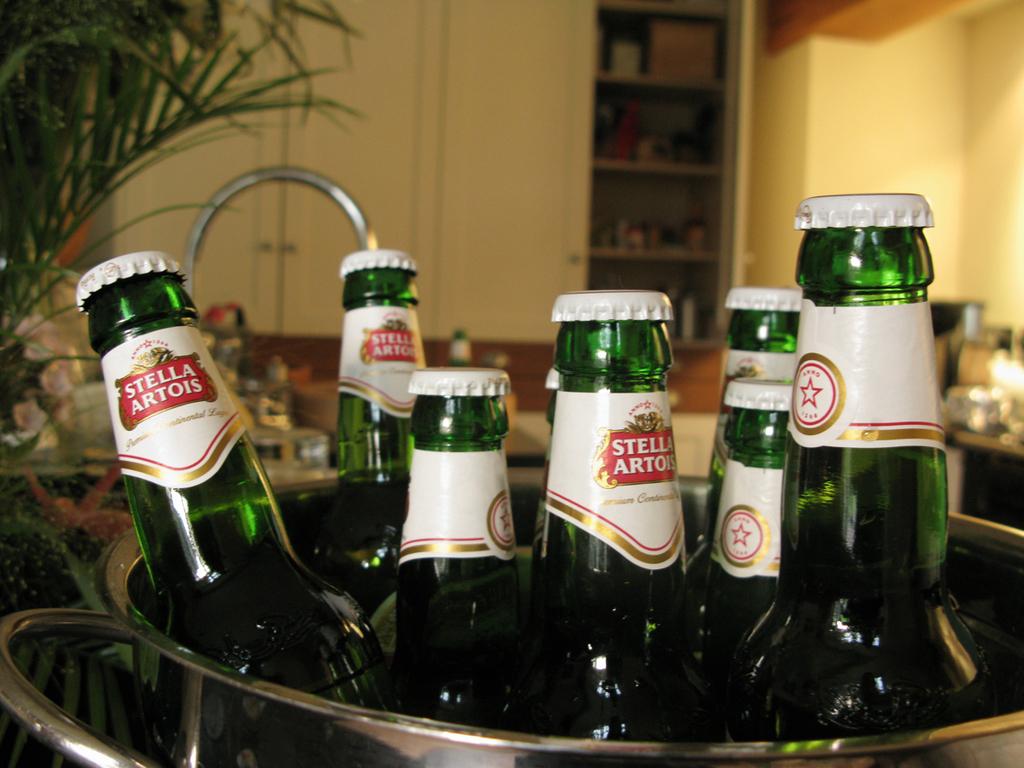What is the name of the beer?
Ensure brevity in your answer.  Stella artois. What type of beer is it?
Your answer should be compact. Stella artois. 